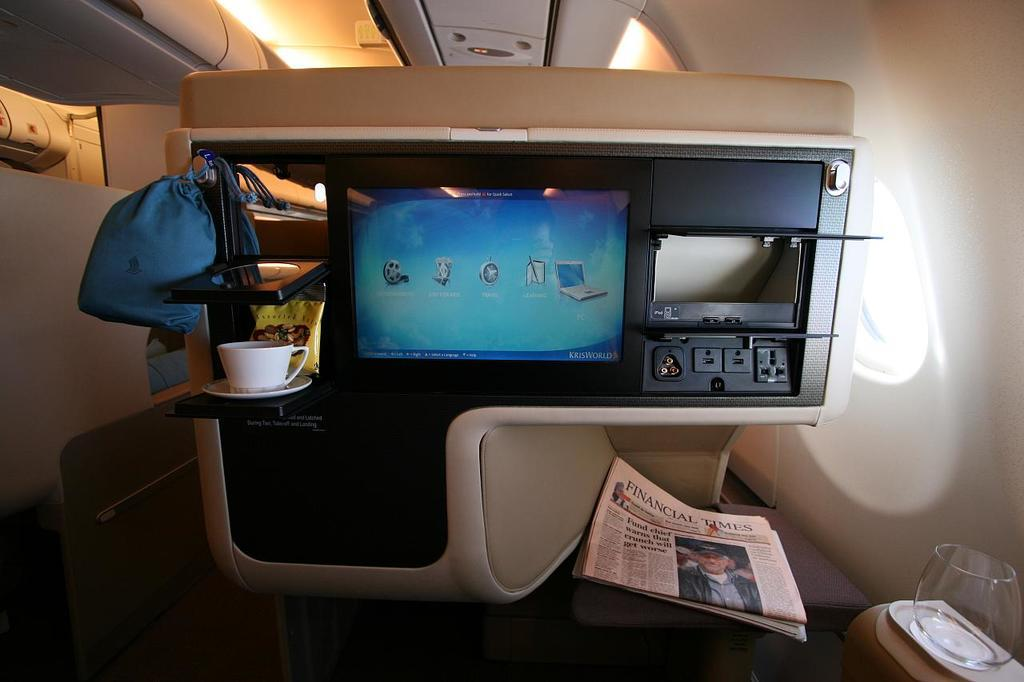Provide a one-sentence caption for the provided image. An airplane entertainment console is shown with a screen with several icons and a Financial Times newspaper below the screen. 